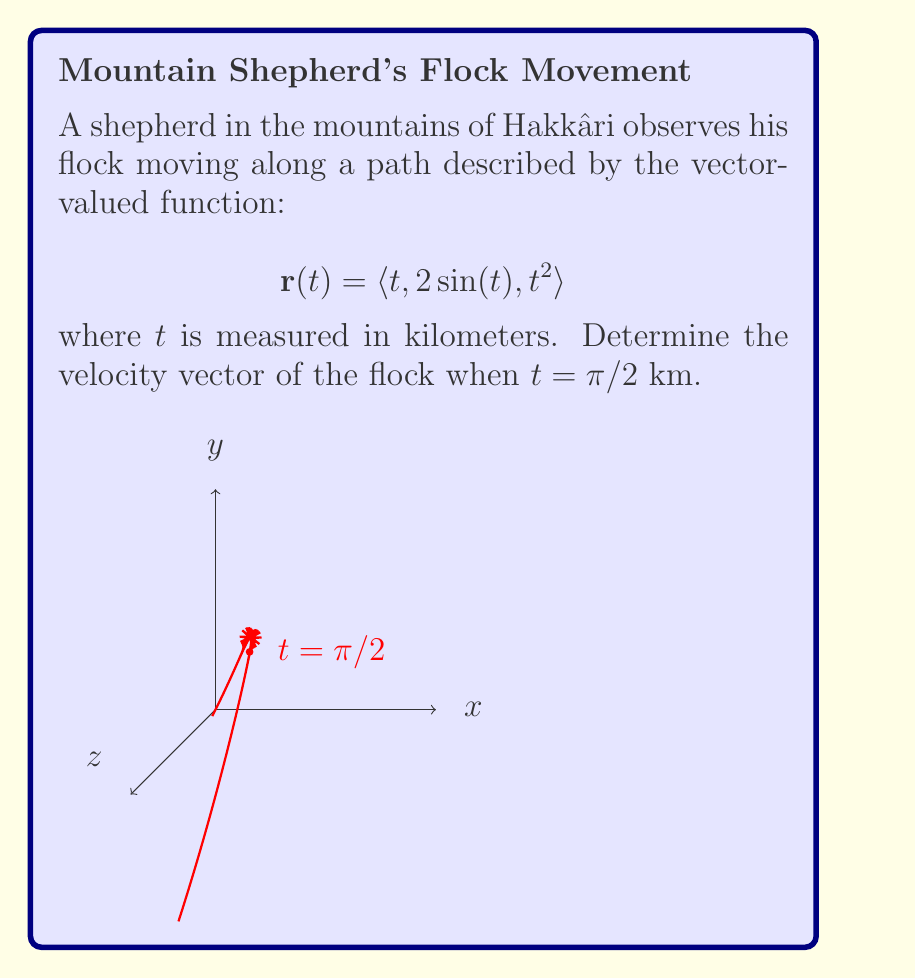Help me with this question. To find the velocity vector, we need to differentiate the position vector $\mathbf{r}(t)$ with respect to $t$:

1) The velocity vector is given by $\mathbf{v}(t) = \frac{d\mathbf{r}}{dt}$

2) Let's differentiate each component:
   
   $\frac{d}{dt}(t) = 1$
   
   $\frac{d}{dt}(2\sin(t)) = 2\cos(t)$
   
   $\frac{d}{dt}(t^2) = 2t$

3) Therefore, the velocity vector is:

   $$\mathbf{v}(t) = \langle 1, 2\cos(t), 2t \rangle$$

4) Now, we need to evaluate this at $t = \pi/2$:

   $$\mathbf{v}(\pi/2) = \langle 1, 2\cos(\pi/2), 2(\pi/2) \rangle$$

5) Simplify:
   $\cos(\pi/2) = 0$
   $2(\pi/2) = \pi$

6) Thus, the final velocity vector is:

   $$\mathbf{v}(\pi/2) = \langle 1, 0, \pi \rangle$$

This vector represents the instantaneous velocity of the flock at $t = \pi/2$ km along their path.
Answer: $\langle 1, 0, \pi \rangle$ 